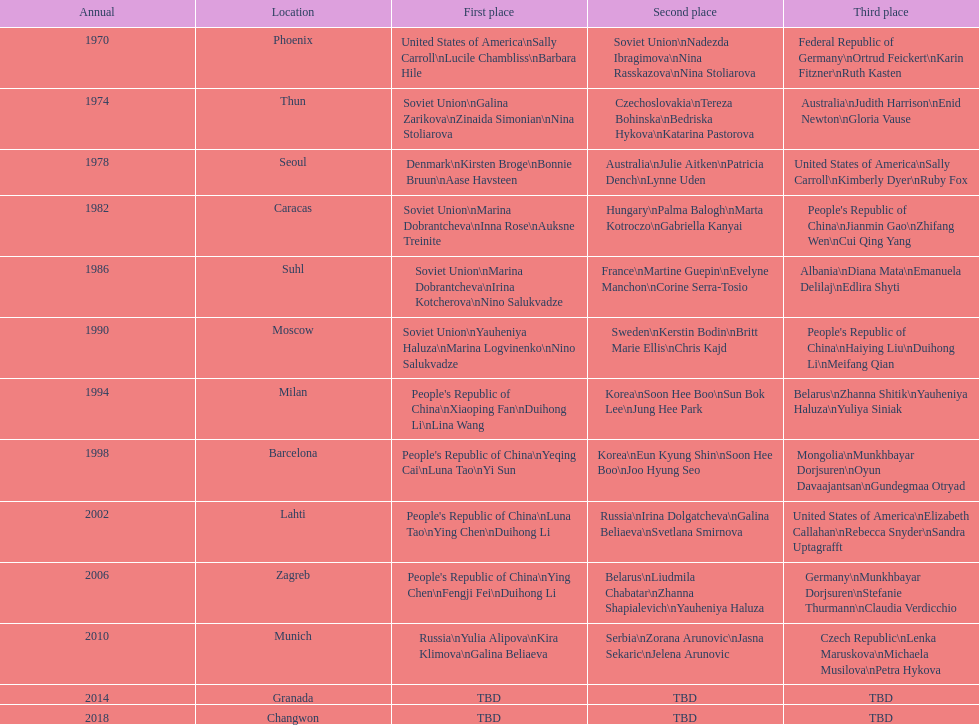Which country is listed the most under the silver column? Korea. 